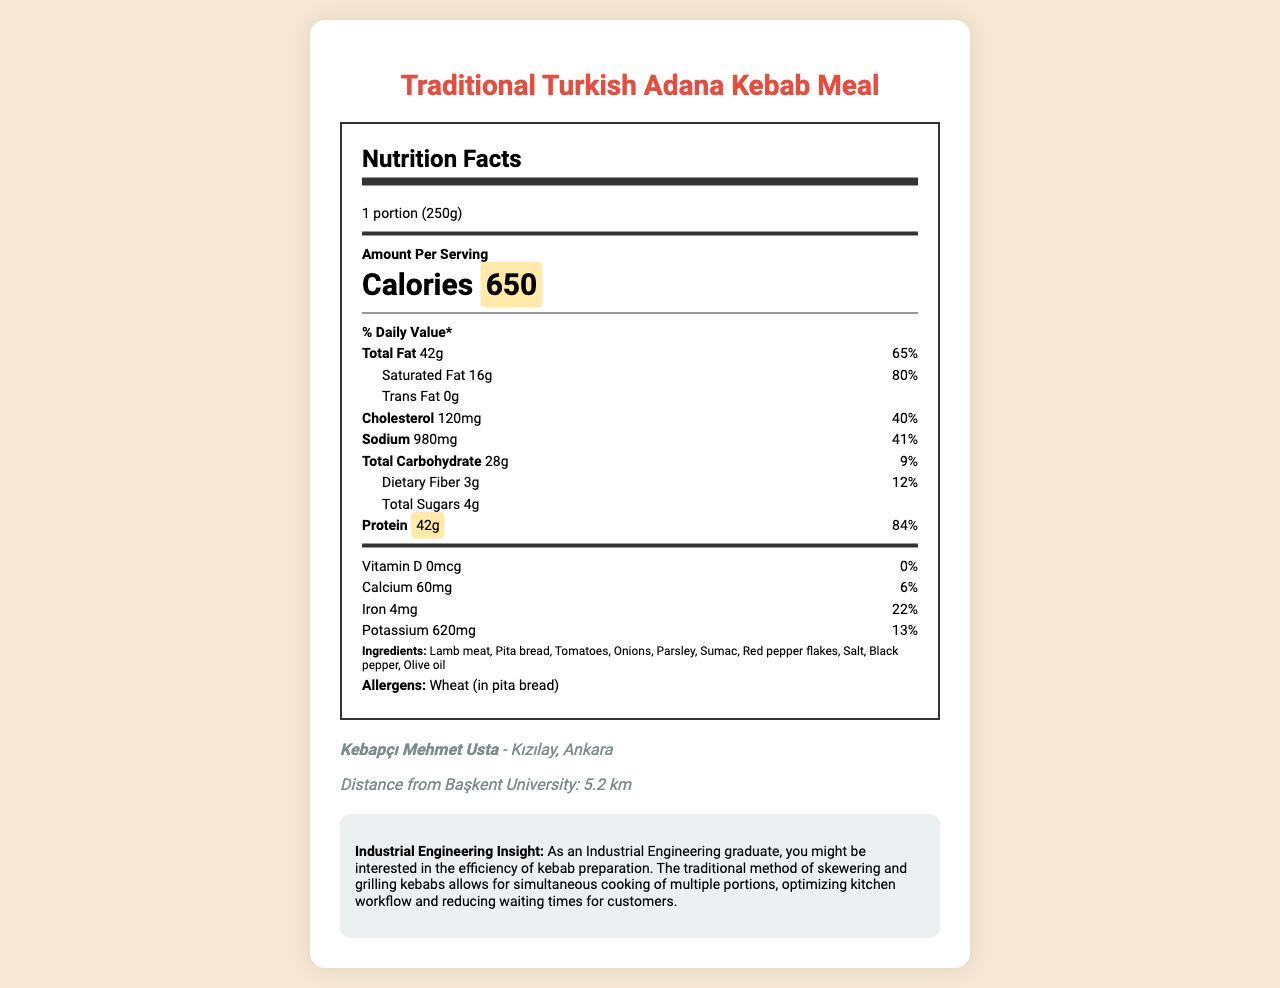what is the serving size of the Traditional Turkish Adana Kebab Meal? The document mentions that the serving size is 1 portion (250g) at the top.
Answer: 1 portion (250g) how many calories does one serving of Traditional Turkish Adana Kebab Meal contain? The calorie information section highlights that one serving contains 650 calories.
Answer: 650 what is the total fat content in grams and the corresponding daily value percentage? The nutrition facts section indicates the total fat content as 42g and the daily value as 65%.
Answer: 42g, 65% what is the amount of protein in one serving? The nutrition label highlights the protein amount as 42g with a daily value of 84%.
Answer: 42g list three main ingredients in the Traditional Turkish Adana Kebab Meal. The ingredients listed in the document include Lamb meat, Pita bread, and Tomatoes among others.
Answer: Lamb meat, Pita bread, Tomatoes which of the following is true about the Traditional Turkish Adana Kebab Meal? A. It is low in carbohydrates B. It is low in protein C. It is a good source of iron D. It contains high amounts of vitamin D The nutritional highlights indicate that it is a good source of iron.
Answer: C how many grams of dietary fiber are in one serving? I. 2 II. 3 III. 4 IV. 5 The nutrition label specifies that one serving contains 3 grams of dietary fiber with a 12% daily value.
Answer: II. 3 is there any trans fat in this meal? The nutrition label indicates that trans fat amount is 0g.
Answer: No does the Traditional Turkish Adana Kebab Meal contain any allergens? The document lists Wheat (in pita bread) as an allergen.
Answer: Yes summarize the main nutritional information of the Traditional Turkish Adana Kebab Meal. The nutrition label highlights a detailed breakdown of macronutrients and micronutrients for the kebab meal, emphasizing its high protein content and iron source.
Answer: The meal contains 650 calories per serving, high protein (42g), significant total fat (42g), and some important micronutrients like iron and potassium. It is ideal as a high-protein and good iron source meal. what is the preparation method of the Adana Kebab? The document notes that the preparation method for the Adana Kebab is grilled.
Answer: Grilled what is the restaurant name and where is it located? The restaurant information reveals that the meal is from Kebapçı Mehmet Usta, located in Kızılay, Ankara.
Answer: Kebapçı Mehmet Usta, Kızılay, Ankara how much calcium does this meal provide as a percentage of the daily value? The nutrition data indicates the calcium content as 60mg which contributes to 6% of the daily value.
Answer: 6% how many kilometers is the restaurant from Başkent University? The restaurant information section mentions that it is 5.2 km from Başkent University.
Answer: 5.2 km why is the Traditional Turkish Adana Kebab Meal considered efficient in preparation from an industrial engineering perspective? The engineering insight highlights that simultaneous cooking through skewering and grilling improves kitchen efficiency and reduces customer waiting times.
Answer: The traditional method of skewering and grilling allows simultaneous cooking of multiple portions, optimizing kitchen workflow and reducing waiting times. how many nectars are used in Kebapçı Mehmet Usta's Traditional Turkish Adana Kebab Meal? The document does not provide information on any nectars used in the meal.
Answer: I don't know 